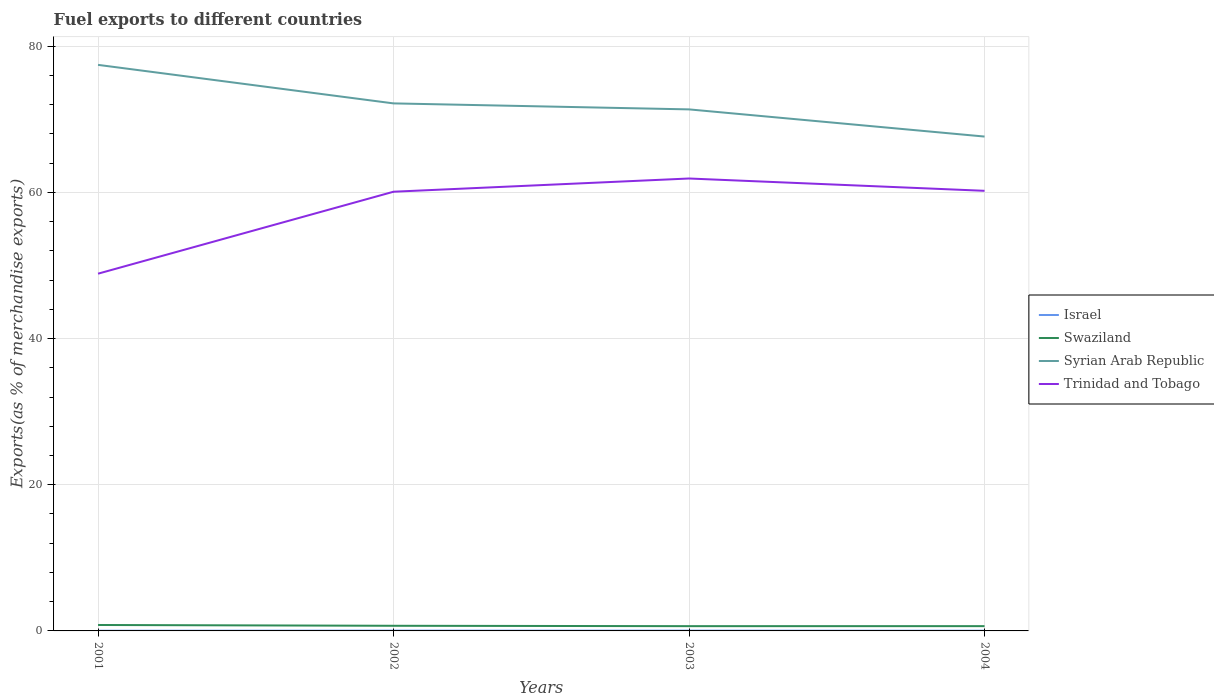Does the line corresponding to Swaziland intersect with the line corresponding to Israel?
Keep it short and to the point. No. Across all years, what is the maximum percentage of exports to different countries in Trinidad and Tobago?
Provide a succinct answer. 48.87. In which year was the percentage of exports to different countries in Israel maximum?
Ensure brevity in your answer.  2001. What is the total percentage of exports to different countries in Syrian Arab Republic in the graph?
Your answer should be very brief. 5.27. What is the difference between the highest and the second highest percentage of exports to different countries in Swaziland?
Your answer should be very brief. 0.16. What is the difference between the highest and the lowest percentage of exports to different countries in Swaziland?
Provide a short and direct response. 1. How many lines are there?
Your answer should be very brief. 4. How many years are there in the graph?
Offer a terse response. 4. Does the graph contain any zero values?
Provide a succinct answer. No. Does the graph contain grids?
Your response must be concise. Yes. How are the legend labels stacked?
Make the answer very short. Vertical. What is the title of the graph?
Provide a succinct answer. Fuel exports to different countries. What is the label or title of the Y-axis?
Offer a terse response. Exports(as % of merchandise exports). What is the Exports(as % of merchandise exports) in Israel in 2001?
Make the answer very short. 0.02. What is the Exports(as % of merchandise exports) in Swaziland in 2001?
Offer a very short reply. 0.81. What is the Exports(as % of merchandise exports) of Syrian Arab Republic in 2001?
Provide a succinct answer. 77.44. What is the Exports(as % of merchandise exports) in Trinidad and Tobago in 2001?
Offer a terse response. 48.87. What is the Exports(as % of merchandise exports) in Israel in 2002?
Provide a succinct answer. 0.04. What is the Exports(as % of merchandise exports) in Swaziland in 2002?
Your answer should be compact. 0.7. What is the Exports(as % of merchandise exports) of Syrian Arab Republic in 2002?
Your answer should be compact. 72.17. What is the Exports(as % of merchandise exports) of Trinidad and Tobago in 2002?
Your response must be concise. 60.08. What is the Exports(as % of merchandise exports) of Israel in 2003?
Make the answer very short. 0.04. What is the Exports(as % of merchandise exports) in Swaziland in 2003?
Your answer should be very brief. 0.65. What is the Exports(as % of merchandise exports) of Syrian Arab Republic in 2003?
Provide a succinct answer. 71.35. What is the Exports(as % of merchandise exports) of Trinidad and Tobago in 2003?
Ensure brevity in your answer.  61.89. What is the Exports(as % of merchandise exports) of Israel in 2004?
Give a very brief answer. 0.03. What is the Exports(as % of merchandise exports) of Swaziland in 2004?
Keep it short and to the point. 0.65. What is the Exports(as % of merchandise exports) in Syrian Arab Republic in 2004?
Offer a terse response. 67.63. What is the Exports(as % of merchandise exports) in Trinidad and Tobago in 2004?
Give a very brief answer. 60.21. Across all years, what is the maximum Exports(as % of merchandise exports) in Israel?
Give a very brief answer. 0.04. Across all years, what is the maximum Exports(as % of merchandise exports) of Swaziland?
Offer a very short reply. 0.81. Across all years, what is the maximum Exports(as % of merchandise exports) in Syrian Arab Republic?
Make the answer very short. 77.44. Across all years, what is the maximum Exports(as % of merchandise exports) in Trinidad and Tobago?
Keep it short and to the point. 61.89. Across all years, what is the minimum Exports(as % of merchandise exports) in Israel?
Give a very brief answer. 0.02. Across all years, what is the minimum Exports(as % of merchandise exports) of Swaziland?
Your answer should be compact. 0.65. Across all years, what is the minimum Exports(as % of merchandise exports) of Syrian Arab Republic?
Keep it short and to the point. 67.63. Across all years, what is the minimum Exports(as % of merchandise exports) of Trinidad and Tobago?
Offer a very short reply. 48.87. What is the total Exports(as % of merchandise exports) in Israel in the graph?
Offer a terse response. 0.13. What is the total Exports(as % of merchandise exports) of Swaziland in the graph?
Provide a short and direct response. 2.82. What is the total Exports(as % of merchandise exports) in Syrian Arab Republic in the graph?
Your response must be concise. 288.58. What is the total Exports(as % of merchandise exports) in Trinidad and Tobago in the graph?
Make the answer very short. 231.05. What is the difference between the Exports(as % of merchandise exports) in Israel in 2001 and that in 2002?
Keep it short and to the point. -0.02. What is the difference between the Exports(as % of merchandise exports) of Swaziland in 2001 and that in 2002?
Give a very brief answer. 0.11. What is the difference between the Exports(as % of merchandise exports) of Syrian Arab Republic in 2001 and that in 2002?
Keep it short and to the point. 5.27. What is the difference between the Exports(as % of merchandise exports) of Trinidad and Tobago in 2001 and that in 2002?
Make the answer very short. -11.21. What is the difference between the Exports(as % of merchandise exports) in Israel in 2001 and that in 2003?
Your answer should be compact. -0.01. What is the difference between the Exports(as % of merchandise exports) in Swaziland in 2001 and that in 2003?
Make the answer very short. 0.16. What is the difference between the Exports(as % of merchandise exports) of Syrian Arab Republic in 2001 and that in 2003?
Your answer should be very brief. 6.09. What is the difference between the Exports(as % of merchandise exports) in Trinidad and Tobago in 2001 and that in 2003?
Your answer should be compact. -13.02. What is the difference between the Exports(as % of merchandise exports) in Israel in 2001 and that in 2004?
Your answer should be very brief. -0. What is the difference between the Exports(as % of merchandise exports) of Swaziland in 2001 and that in 2004?
Ensure brevity in your answer.  0.16. What is the difference between the Exports(as % of merchandise exports) of Syrian Arab Republic in 2001 and that in 2004?
Make the answer very short. 9.81. What is the difference between the Exports(as % of merchandise exports) in Trinidad and Tobago in 2001 and that in 2004?
Offer a very short reply. -11.34. What is the difference between the Exports(as % of merchandise exports) of Israel in 2002 and that in 2003?
Offer a very short reply. 0. What is the difference between the Exports(as % of merchandise exports) in Swaziland in 2002 and that in 2003?
Provide a short and direct response. 0.05. What is the difference between the Exports(as % of merchandise exports) in Syrian Arab Republic in 2002 and that in 2003?
Your answer should be very brief. 0.82. What is the difference between the Exports(as % of merchandise exports) of Trinidad and Tobago in 2002 and that in 2003?
Your answer should be very brief. -1.81. What is the difference between the Exports(as % of merchandise exports) in Israel in 2002 and that in 2004?
Your response must be concise. 0.01. What is the difference between the Exports(as % of merchandise exports) of Swaziland in 2002 and that in 2004?
Keep it short and to the point. 0.05. What is the difference between the Exports(as % of merchandise exports) of Syrian Arab Republic in 2002 and that in 2004?
Your answer should be compact. 4.54. What is the difference between the Exports(as % of merchandise exports) of Trinidad and Tobago in 2002 and that in 2004?
Keep it short and to the point. -0.12. What is the difference between the Exports(as % of merchandise exports) of Israel in 2003 and that in 2004?
Ensure brevity in your answer.  0.01. What is the difference between the Exports(as % of merchandise exports) in Swaziland in 2003 and that in 2004?
Your answer should be compact. -0. What is the difference between the Exports(as % of merchandise exports) in Syrian Arab Republic in 2003 and that in 2004?
Offer a terse response. 3.72. What is the difference between the Exports(as % of merchandise exports) in Trinidad and Tobago in 2003 and that in 2004?
Offer a very short reply. 1.69. What is the difference between the Exports(as % of merchandise exports) of Israel in 2001 and the Exports(as % of merchandise exports) of Swaziland in 2002?
Your response must be concise. -0.68. What is the difference between the Exports(as % of merchandise exports) in Israel in 2001 and the Exports(as % of merchandise exports) in Syrian Arab Republic in 2002?
Ensure brevity in your answer.  -72.14. What is the difference between the Exports(as % of merchandise exports) in Israel in 2001 and the Exports(as % of merchandise exports) in Trinidad and Tobago in 2002?
Ensure brevity in your answer.  -60.06. What is the difference between the Exports(as % of merchandise exports) of Swaziland in 2001 and the Exports(as % of merchandise exports) of Syrian Arab Republic in 2002?
Provide a short and direct response. -71.35. What is the difference between the Exports(as % of merchandise exports) of Swaziland in 2001 and the Exports(as % of merchandise exports) of Trinidad and Tobago in 2002?
Ensure brevity in your answer.  -59.27. What is the difference between the Exports(as % of merchandise exports) of Syrian Arab Republic in 2001 and the Exports(as % of merchandise exports) of Trinidad and Tobago in 2002?
Provide a short and direct response. 17.35. What is the difference between the Exports(as % of merchandise exports) in Israel in 2001 and the Exports(as % of merchandise exports) in Swaziland in 2003?
Offer a very short reply. -0.63. What is the difference between the Exports(as % of merchandise exports) of Israel in 2001 and the Exports(as % of merchandise exports) of Syrian Arab Republic in 2003?
Ensure brevity in your answer.  -71.32. What is the difference between the Exports(as % of merchandise exports) of Israel in 2001 and the Exports(as % of merchandise exports) of Trinidad and Tobago in 2003?
Offer a very short reply. -61.87. What is the difference between the Exports(as % of merchandise exports) of Swaziland in 2001 and the Exports(as % of merchandise exports) of Syrian Arab Republic in 2003?
Offer a very short reply. -70.53. What is the difference between the Exports(as % of merchandise exports) of Swaziland in 2001 and the Exports(as % of merchandise exports) of Trinidad and Tobago in 2003?
Give a very brief answer. -61.08. What is the difference between the Exports(as % of merchandise exports) of Syrian Arab Republic in 2001 and the Exports(as % of merchandise exports) of Trinidad and Tobago in 2003?
Provide a succinct answer. 15.54. What is the difference between the Exports(as % of merchandise exports) in Israel in 2001 and the Exports(as % of merchandise exports) in Swaziland in 2004?
Ensure brevity in your answer.  -0.63. What is the difference between the Exports(as % of merchandise exports) in Israel in 2001 and the Exports(as % of merchandise exports) in Syrian Arab Republic in 2004?
Offer a very short reply. -67.6. What is the difference between the Exports(as % of merchandise exports) of Israel in 2001 and the Exports(as % of merchandise exports) of Trinidad and Tobago in 2004?
Make the answer very short. -60.18. What is the difference between the Exports(as % of merchandise exports) of Swaziland in 2001 and the Exports(as % of merchandise exports) of Syrian Arab Republic in 2004?
Provide a succinct answer. -66.82. What is the difference between the Exports(as % of merchandise exports) of Swaziland in 2001 and the Exports(as % of merchandise exports) of Trinidad and Tobago in 2004?
Ensure brevity in your answer.  -59.39. What is the difference between the Exports(as % of merchandise exports) in Syrian Arab Republic in 2001 and the Exports(as % of merchandise exports) in Trinidad and Tobago in 2004?
Offer a very short reply. 17.23. What is the difference between the Exports(as % of merchandise exports) in Israel in 2002 and the Exports(as % of merchandise exports) in Swaziland in 2003?
Your answer should be compact. -0.61. What is the difference between the Exports(as % of merchandise exports) in Israel in 2002 and the Exports(as % of merchandise exports) in Syrian Arab Republic in 2003?
Offer a very short reply. -71.31. What is the difference between the Exports(as % of merchandise exports) in Israel in 2002 and the Exports(as % of merchandise exports) in Trinidad and Tobago in 2003?
Your answer should be very brief. -61.85. What is the difference between the Exports(as % of merchandise exports) of Swaziland in 2002 and the Exports(as % of merchandise exports) of Syrian Arab Republic in 2003?
Offer a very short reply. -70.64. What is the difference between the Exports(as % of merchandise exports) in Swaziland in 2002 and the Exports(as % of merchandise exports) in Trinidad and Tobago in 2003?
Your answer should be very brief. -61.19. What is the difference between the Exports(as % of merchandise exports) of Syrian Arab Republic in 2002 and the Exports(as % of merchandise exports) of Trinidad and Tobago in 2003?
Provide a succinct answer. 10.27. What is the difference between the Exports(as % of merchandise exports) of Israel in 2002 and the Exports(as % of merchandise exports) of Swaziland in 2004?
Provide a short and direct response. -0.61. What is the difference between the Exports(as % of merchandise exports) of Israel in 2002 and the Exports(as % of merchandise exports) of Syrian Arab Republic in 2004?
Provide a short and direct response. -67.59. What is the difference between the Exports(as % of merchandise exports) of Israel in 2002 and the Exports(as % of merchandise exports) of Trinidad and Tobago in 2004?
Your answer should be very brief. -60.17. What is the difference between the Exports(as % of merchandise exports) of Swaziland in 2002 and the Exports(as % of merchandise exports) of Syrian Arab Republic in 2004?
Provide a succinct answer. -66.93. What is the difference between the Exports(as % of merchandise exports) in Swaziland in 2002 and the Exports(as % of merchandise exports) in Trinidad and Tobago in 2004?
Offer a terse response. -59.5. What is the difference between the Exports(as % of merchandise exports) of Syrian Arab Republic in 2002 and the Exports(as % of merchandise exports) of Trinidad and Tobago in 2004?
Offer a very short reply. 11.96. What is the difference between the Exports(as % of merchandise exports) in Israel in 2003 and the Exports(as % of merchandise exports) in Swaziland in 2004?
Your response must be concise. -0.62. What is the difference between the Exports(as % of merchandise exports) of Israel in 2003 and the Exports(as % of merchandise exports) of Syrian Arab Republic in 2004?
Offer a terse response. -67.59. What is the difference between the Exports(as % of merchandise exports) in Israel in 2003 and the Exports(as % of merchandise exports) in Trinidad and Tobago in 2004?
Provide a short and direct response. -60.17. What is the difference between the Exports(as % of merchandise exports) in Swaziland in 2003 and the Exports(as % of merchandise exports) in Syrian Arab Republic in 2004?
Keep it short and to the point. -66.98. What is the difference between the Exports(as % of merchandise exports) of Swaziland in 2003 and the Exports(as % of merchandise exports) of Trinidad and Tobago in 2004?
Your answer should be very brief. -59.56. What is the difference between the Exports(as % of merchandise exports) of Syrian Arab Republic in 2003 and the Exports(as % of merchandise exports) of Trinidad and Tobago in 2004?
Make the answer very short. 11.14. What is the average Exports(as % of merchandise exports) in Israel per year?
Your response must be concise. 0.03. What is the average Exports(as % of merchandise exports) of Swaziland per year?
Offer a terse response. 0.7. What is the average Exports(as % of merchandise exports) of Syrian Arab Republic per year?
Make the answer very short. 72.14. What is the average Exports(as % of merchandise exports) of Trinidad and Tobago per year?
Make the answer very short. 57.76. In the year 2001, what is the difference between the Exports(as % of merchandise exports) of Israel and Exports(as % of merchandise exports) of Swaziland?
Keep it short and to the point. -0.79. In the year 2001, what is the difference between the Exports(as % of merchandise exports) in Israel and Exports(as % of merchandise exports) in Syrian Arab Republic?
Ensure brevity in your answer.  -77.41. In the year 2001, what is the difference between the Exports(as % of merchandise exports) in Israel and Exports(as % of merchandise exports) in Trinidad and Tobago?
Your response must be concise. -48.85. In the year 2001, what is the difference between the Exports(as % of merchandise exports) in Swaziland and Exports(as % of merchandise exports) in Syrian Arab Republic?
Your answer should be very brief. -76.62. In the year 2001, what is the difference between the Exports(as % of merchandise exports) of Swaziland and Exports(as % of merchandise exports) of Trinidad and Tobago?
Your response must be concise. -48.06. In the year 2001, what is the difference between the Exports(as % of merchandise exports) in Syrian Arab Republic and Exports(as % of merchandise exports) in Trinidad and Tobago?
Your response must be concise. 28.57. In the year 2002, what is the difference between the Exports(as % of merchandise exports) in Israel and Exports(as % of merchandise exports) in Swaziland?
Offer a terse response. -0.66. In the year 2002, what is the difference between the Exports(as % of merchandise exports) in Israel and Exports(as % of merchandise exports) in Syrian Arab Republic?
Make the answer very short. -72.13. In the year 2002, what is the difference between the Exports(as % of merchandise exports) in Israel and Exports(as % of merchandise exports) in Trinidad and Tobago?
Provide a succinct answer. -60.04. In the year 2002, what is the difference between the Exports(as % of merchandise exports) in Swaziland and Exports(as % of merchandise exports) in Syrian Arab Republic?
Make the answer very short. -71.46. In the year 2002, what is the difference between the Exports(as % of merchandise exports) of Swaziland and Exports(as % of merchandise exports) of Trinidad and Tobago?
Provide a short and direct response. -59.38. In the year 2002, what is the difference between the Exports(as % of merchandise exports) of Syrian Arab Republic and Exports(as % of merchandise exports) of Trinidad and Tobago?
Provide a succinct answer. 12.08. In the year 2003, what is the difference between the Exports(as % of merchandise exports) of Israel and Exports(as % of merchandise exports) of Swaziland?
Give a very brief answer. -0.61. In the year 2003, what is the difference between the Exports(as % of merchandise exports) in Israel and Exports(as % of merchandise exports) in Syrian Arab Republic?
Offer a very short reply. -71.31. In the year 2003, what is the difference between the Exports(as % of merchandise exports) in Israel and Exports(as % of merchandise exports) in Trinidad and Tobago?
Offer a terse response. -61.85. In the year 2003, what is the difference between the Exports(as % of merchandise exports) in Swaziland and Exports(as % of merchandise exports) in Syrian Arab Republic?
Make the answer very short. -70.7. In the year 2003, what is the difference between the Exports(as % of merchandise exports) in Swaziland and Exports(as % of merchandise exports) in Trinidad and Tobago?
Provide a succinct answer. -61.24. In the year 2003, what is the difference between the Exports(as % of merchandise exports) of Syrian Arab Republic and Exports(as % of merchandise exports) of Trinidad and Tobago?
Provide a succinct answer. 9.45. In the year 2004, what is the difference between the Exports(as % of merchandise exports) of Israel and Exports(as % of merchandise exports) of Swaziland?
Offer a terse response. -0.63. In the year 2004, what is the difference between the Exports(as % of merchandise exports) in Israel and Exports(as % of merchandise exports) in Syrian Arab Republic?
Your answer should be very brief. -67.6. In the year 2004, what is the difference between the Exports(as % of merchandise exports) of Israel and Exports(as % of merchandise exports) of Trinidad and Tobago?
Provide a short and direct response. -60.18. In the year 2004, what is the difference between the Exports(as % of merchandise exports) of Swaziland and Exports(as % of merchandise exports) of Syrian Arab Republic?
Provide a succinct answer. -66.98. In the year 2004, what is the difference between the Exports(as % of merchandise exports) of Swaziland and Exports(as % of merchandise exports) of Trinidad and Tobago?
Offer a terse response. -59.55. In the year 2004, what is the difference between the Exports(as % of merchandise exports) in Syrian Arab Republic and Exports(as % of merchandise exports) in Trinidad and Tobago?
Keep it short and to the point. 7.42. What is the ratio of the Exports(as % of merchandise exports) of Israel in 2001 to that in 2002?
Provide a succinct answer. 0.61. What is the ratio of the Exports(as % of merchandise exports) of Swaziland in 2001 to that in 2002?
Ensure brevity in your answer.  1.16. What is the ratio of the Exports(as % of merchandise exports) in Syrian Arab Republic in 2001 to that in 2002?
Your answer should be very brief. 1.07. What is the ratio of the Exports(as % of merchandise exports) of Trinidad and Tobago in 2001 to that in 2002?
Your answer should be compact. 0.81. What is the ratio of the Exports(as % of merchandise exports) in Israel in 2001 to that in 2003?
Provide a succinct answer. 0.64. What is the ratio of the Exports(as % of merchandise exports) of Swaziland in 2001 to that in 2003?
Offer a very short reply. 1.25. What is the ratio of the Exports(as % of merchandise exports) of Syrian Arab Republic in 2001 to that in 2003?
Your answer should be very brief. 1.09. What is the ratio of the Exports(as % of merchandise exports) in Trinidad and Tobago in 2001 to that in 2003?
Offer a very short reply. 0.79. What is the ratio of the Exports(as % of merchandise exports) in Israel in 2001 to that in 2004?
Your answer should be compact. 0.89. What is the ratio of the Exports(as % of merchandise exports) of Swaziland in 2001 to that in 2004?
Your answer should be compact. 1.24. What is the ratio of the Exports(as % of merchandise exports) in Syrian Arab Republic in 2001 to that in 2004?
Offer a very short reply. 1.15. What is the ratio of the Exports(as % of merchandise exports) of Trinidad and Tobago in 2001 to that in 2004?
Your answer should be compact. 0.81. What is the ratio of the Exports(as % of merchandise exports) in Israel in 2002 to that in 2003?
Offer a very short reply. 1.05. What is the ratio of the Exports(as % of merchandise exports) of Swaziland in 2002 to that in 2003?
Provide a short and direct response. 1.08. What is the ratio of the Exports(as % of merchandise exports) in Syrian Arab Republic in 2002 to that in 2003?
Your answer should be compact. 1.01. What is the ratio of the Exports(as % of merchandise exports) of Trinidad and Tobago in 2002 to that in 2003?
Your answer should be very brief. 0.97. What is the ratio of the Exports(as % of merchandise exports) of Israel in 2002 to that in 2004?
Ensure brevity in your answer.  1.47. What is the ratio of the Exports(as % of merchandise exports) in Swaziland in 2002 to that in 2004?
Offer a very short reply. 1.08. What is the ratio of the Exports(as % of merchandise exports) of Syrian Arab Republic in 2002 to that in 2004?
Offer a terse response. 1.07. What is the ratio of the Exports(as % of merchandise exports) of Trinidad and Tobago in 2002 to that in 2004?
Provide a succinct answer. 1. What is the ratio of the Exports(as % of merchandise exports) of Israel in 2003 to that in 2004?
Your response must be concise. 1.4. What is the ratio of the Exports(as % of merchandise exports) of Swaziland in 2003 to that in 2004?
Keep it short and to the point. 1. What is the ratio of the Exports(as % of merchandise exports) in Syrian Arab Republic in 2003 to that in 2004?
Give a very brief answer. 1.05. What is the ratio of the Exports(as % of merchandise exports) of Trinidad and Tobago in 2003 to that in 2004?
Offer a terse response. 1.03. What is the difference between the highest and the second highest Exports(as % of merchandise exports) of Israel?
Provide a short and direct response. 0. What is the difference between the highest and the second highest Exports(as % of merchandise exports) of Swaziland?
Provide a short and direct response. 0.11. What is the difference between the highest and the second highest Exports(as % of merchandise exports) of Syrian Arab Republic?
Offer a terse response. 5.27. What is the difference between the highest and the second highest Exports(as % of merchandise exports) of Trinidad and Tobago?
Your response must be concise. 1.69. What is the difference between the highest and the lowest Exports(as % of merchandise exports) in Israel?
Provide a succinct answer. 0.02. What is the difference between the highest and the lowest Exports(as % of merchandise exports) in Swaziland?
Ensure brevity in your answer.  0.16. What is the difference between the highest and the lowest Exports(as % of merchandise exports) of Syrian Arab Republic?
Ensure brevity in your answer.  9.81. What is the difference between the highest and the lowest Exports(as % of merchandise exports) of Trinidad and Tobago?
Your answer should be very brief. 13.02. 